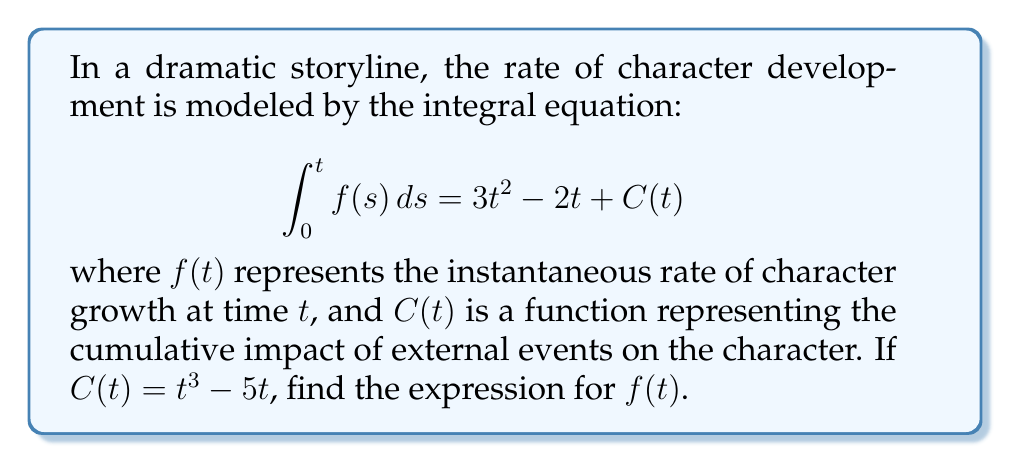Can you solve this math problem? To solve this integral equation, we need to follow these steps:

1) First, we recognize that the left side of the equation is an indefinite integral of $f(t)$ with respect to $t$.

2) To find $f(t)$, we need to differentiate both sides of the equation with respect to $t$:

   $$\frac{d}{dt}\left(\int_0^t f(s) ds\right) = \frac{d}{dt}(3t^2 - 2t + C(t))$$

3) Using the Fundamental Theorem of Calculus, we know that:

   $$\frac{d}{dt}\left(\int_0^t f(s) ds\right) = f(t)$$

4) For the right side, we differentiate each term:

   $$\frac{d}{dt}(3t^2 - 2t + C(t)) = 6t - 2 + C'(t)$$

5) We're given that $C(t) = t^3 - 5t$, so we need to find $C'(t)$:

   $$C'(t) = 3t^2 - 5$$

6) Substituting this back into our equation:

   $$f(t) = 6t - 2 + (3t^2 - 5)$$

7) Simplifying:

   $$f(t) = 3t^2 + 6t - 7$$

Therefore, the expression for $f(t)$ is $3t^2 + 6t - 7$.
Answer: $f(t) = 3t^2 + 6t - 7$ 